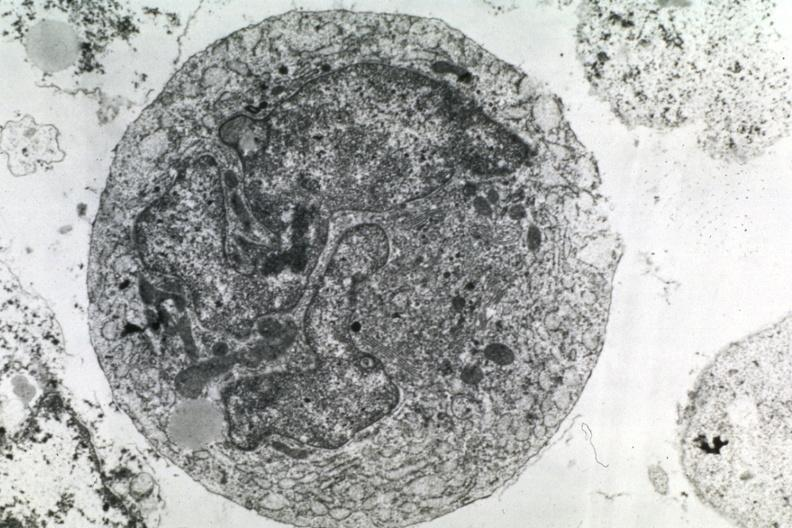what is present?
Answer the question using a single word or phrase. Brain 